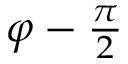<formula> <loc_0><loc_0><loc_500><loc_500>\varphi - { \frac { \pi } { 2 } }</formula> 